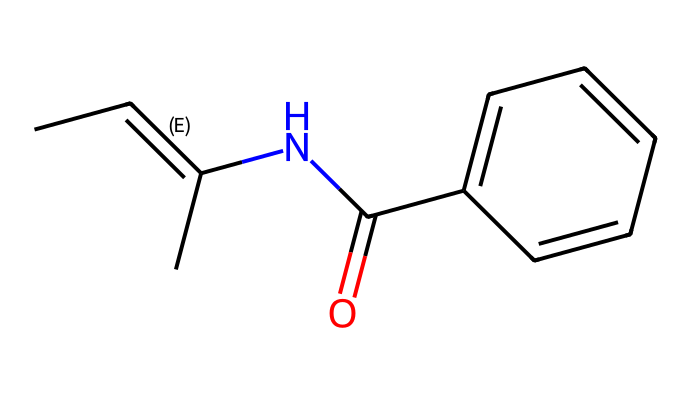What is the functional group present in this chemical? The chemical features a carbonyl group (indicated by the C(=O) notation) which is characteristic of amides or carboxylic acids. In this case, it is connected to a nitrogen, indicating an amide functional group.
Answer: carbonyl How many double bonds are present in the structure? Upon examining the SMILES notation, there is one C/C=C( double bond indicating a double bond between two carbon atoms, resulting in a total of one double bond in the structure.
Answer: one What type of isomerism does this chemical exhibit? The presence of the C/C=C( double bond allows for geometric isomerism, specifically E-Z isomerism, based on the arrangement of substituents around the double bond.
Answer: E-Z isomerism What part of the molecule contributes to its corrosion inhibiting properties? The nitrogen atom (N), which is part of the amide group, enhances the ability of the molecule to interact with metal surfaces and provide protective layers against corrosion.
Answer: nitrogen How many aromatic rings are present in the compound? The structure includes one aromatic ring formed by the benzene derivative (c1ccccc1), indicating a total of one aromatic ring.
Answer: one Which substituent creates the potential for stereoisomerism? The C and C adjacent to the double bond have different substituents (one with another carbon and the other with a nitrogen), creating different positioning (E or Z) around the double bond.
Answer: substituents 